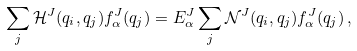Convert formula to latex. <formula><loc_0><loc_0><loc_500><loc_500>\sum _ { j } { \mathcal { H } ^ { J } ( q _ { i } , q _ { j } ) f ^ { J } _ { \alpha } ( q _ { j } ) } = E ^ { J } _ { \alpha } \sum _ { j } { \mathcal { N } ^ { J } ( q _ { i } , q _ { j } ) f ^ { J } _ { \alpha } ( q _ { j } ) } \, ,</formula> 